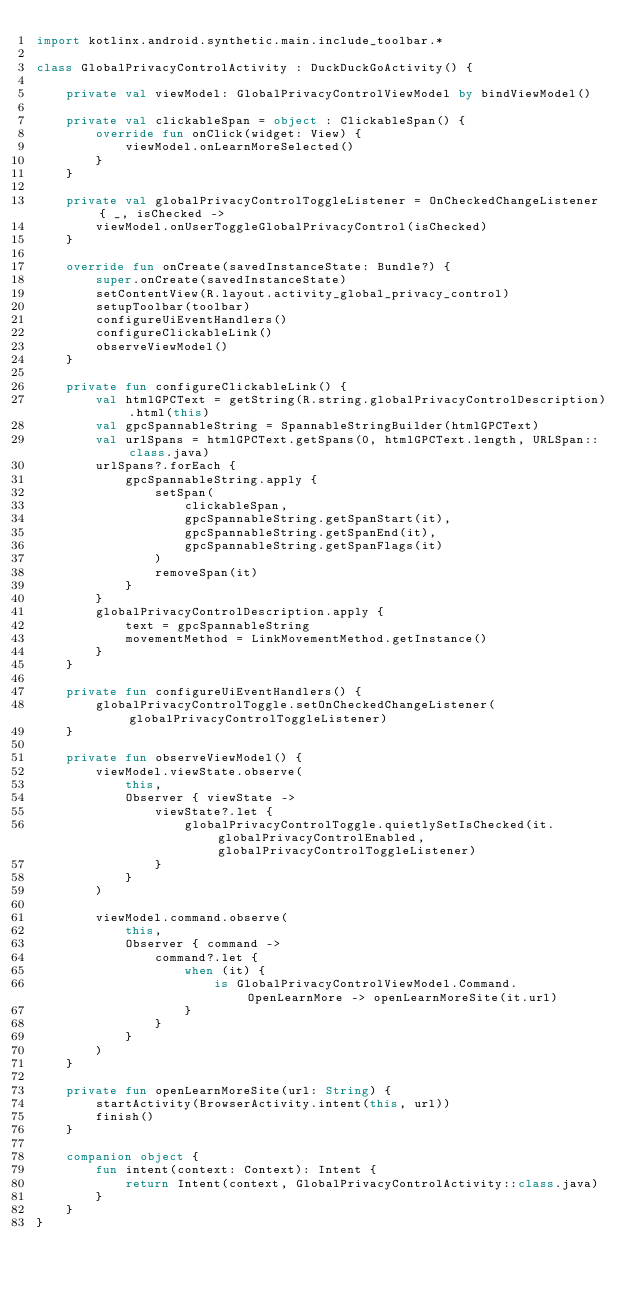<code> <loc_0><loc_0><loc_500><loc_500><_Kotlin_>import kotlinx.android.synthetic.main.include_toolbar.*

class GlobalPrivacyControlActivity : DuckDuckGoActivity() {

    private val viewModel: GlobalPrivacyControlViewModel by bindViewModel()

    private val clickableSpan = object : ClickableSpan() {
        override fun onClick(widget: View) {
            viewModel.onLearnMoreSelected()
        }
    }

    private val globalPrivacyControlToggleListener = OnCheckedChangeListener { _, isChecked ->
        viewModel.onUserToggleGlobalPrivacyControl(isChecked)
    }

    override fun onCreate(savedInstanceState: Bundle?) {
        super.onCreate(savedInstanceState)
        setContentView(R.layout.activity_global_privacy_control)
        setupToolbar(toolbar)
        configureUiEventHandlers()
        configureClickableLink()
        observeViewModel()
    }

    private fun configureClickableLink() {
        val htmlGPCText = getString(R.string.globalPrivacyControlDescription).html(this)
        val gpcSpannableString = SpannableStringBuilder(htmlGPCText)
        val urlSpans = htmlGPCText.getSpans(0, htmlGPCText.length, URLSpan::class.java)
        urlSpans?.forEach {
            gpcSpannableString.apply {
                setSpan(
                    clickableSpan,
                    gpcSpannableString.getSpanStart(it),
                    gpcSpannableString.getSpanEnd(it),
                    gpcSpannableString.getSpanFlags(it)
                )
                removeSpan(it)
            }
        }
        globalPrivacyControlDescription.apply {
            text = gpcSpannableString
            movementMethod = LinkMovementMethod.getInstance()
        }
    }

    private fun configureUiEventHandlers() {
        globalPrivacyControlToggle.setOnCheckedChangeListener(globalPrivacyControlToggleListener)
    }

    private fun observeViewModel() {
        viewModel.viewState.observe(
            this,
            Observer { viewState ->
                viewState?.let {
                    globalPrivacyControlToggle.quietlySetIsChecked(it.globalPrivacyControlEnabled, globalPrivacyControlToggleListener)
                }
            }
        )

        viewModel.command.observe(
            this,
            Observer { command ->
                command?.let {
                    when (it) {
                        is GlobalPrivacyControlViewModel.Command.OpenLearnMore -> openLearnMoreSite(it.url)
                    }
                }
            }
        )
    }

    private fun openLearnMoreSite(url: String) {
        startActivity(BrowserActivity.intent(this, url))
        finish()
    }

    companion object {
        fun intent(context: Context): Intent {
            return Intent(context, GlobalPrivacyControlActivity::class.java)
        }
    }
}
</code> 